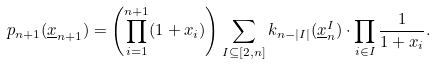Convert formula to latex. <formula><loc_0><loc_0><loc_500><loc_500>p _ { n + 1 } ( \underline { x } _ { n + 1 } ) = \left ( \prod _ { i = 1 } ^ { n + 1 } ( 1 + x _ { i } ) \right ) \sum _ { I \subseteq [ 2 , n ] } k _ { n - | I | } ( \underline { x } _ { n } ^ { I } ) \cdot \prod _ { i \in I } \frac { 1 } { 1 + x _ { i } } .</formula> 